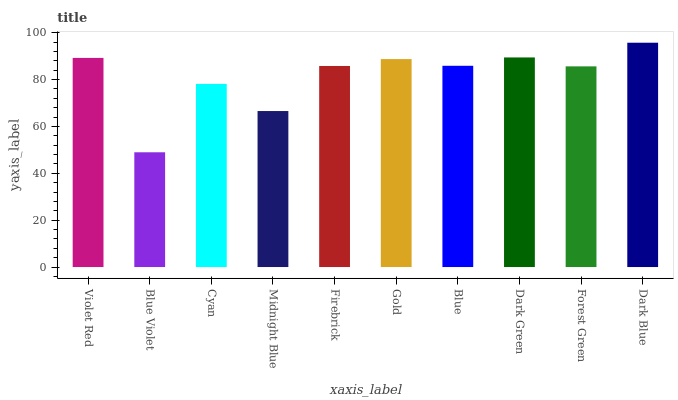Is Blue Violet the minimum?
Answer yes or no. Yes. Is Dark Blue the maximum?
Answer yes or no. Yes. Is Cyan the minimum?
Answer yes or no. No. Is Cyan the maximum?
Answer yes or no. No. Is Cyan greater than Blue Violet?
Answer yes or no. Yes. Is Blue Violet less than Cyan?
Answer yes or no. Yes. Is Blue Violet greater than Cyan?
Answer yes or no. No. Is Cyan less than Blue Violet?
Answer yes or no. No. Is Blue the high median?
Answer yes or no. Yes. Is Firebrick the low median?
Answer yes or no. Yes. Is Dark Green the high median?
Answer yes or no. No. Is Blue Violet the low median?
Answer yes or no. No. 